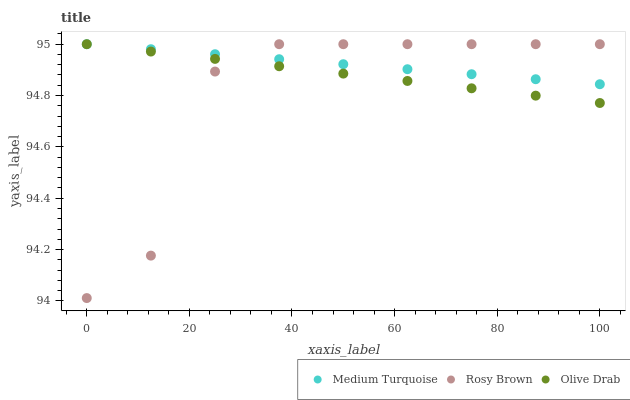Does Rosy Brown have the minimum area under the curve?
Answer yes or no. Yes. Does Medium Turquoise have the maximum area under the curve?
Answer yes or no. Yes. Does Olive Drab have the minimum area under the curve?
Answer yes or no. No. Does Olive Drab have the maximum area under the curve?
Answer yes or no. No. Is Medium Turquoise the smoothest?
Answer yes or no. Yes. Is Rosy Brown the roughest?
Answer yes or no. Yes. Is Olive Drab the smoothest?
Answer yes or no. No. Is Olive Drab the roughest?
Answer yes or no. No. Does Rosy Brown have the lowest value?
Answer yes or no. Yes. Does Olive Drab have the lowest value?
Answer yes or no. No. Does Medium Turquoise have the highest value?
Answer yes or no. Yes. Does Rosy Brown intersect Olive Drab?
Answer yes or no. Yes. Is Rosy Brown less than Olive Drab?
Answer yes or no. No. Is Rosy Brown greater than Olive Drab?
Answer yes or no. No. 